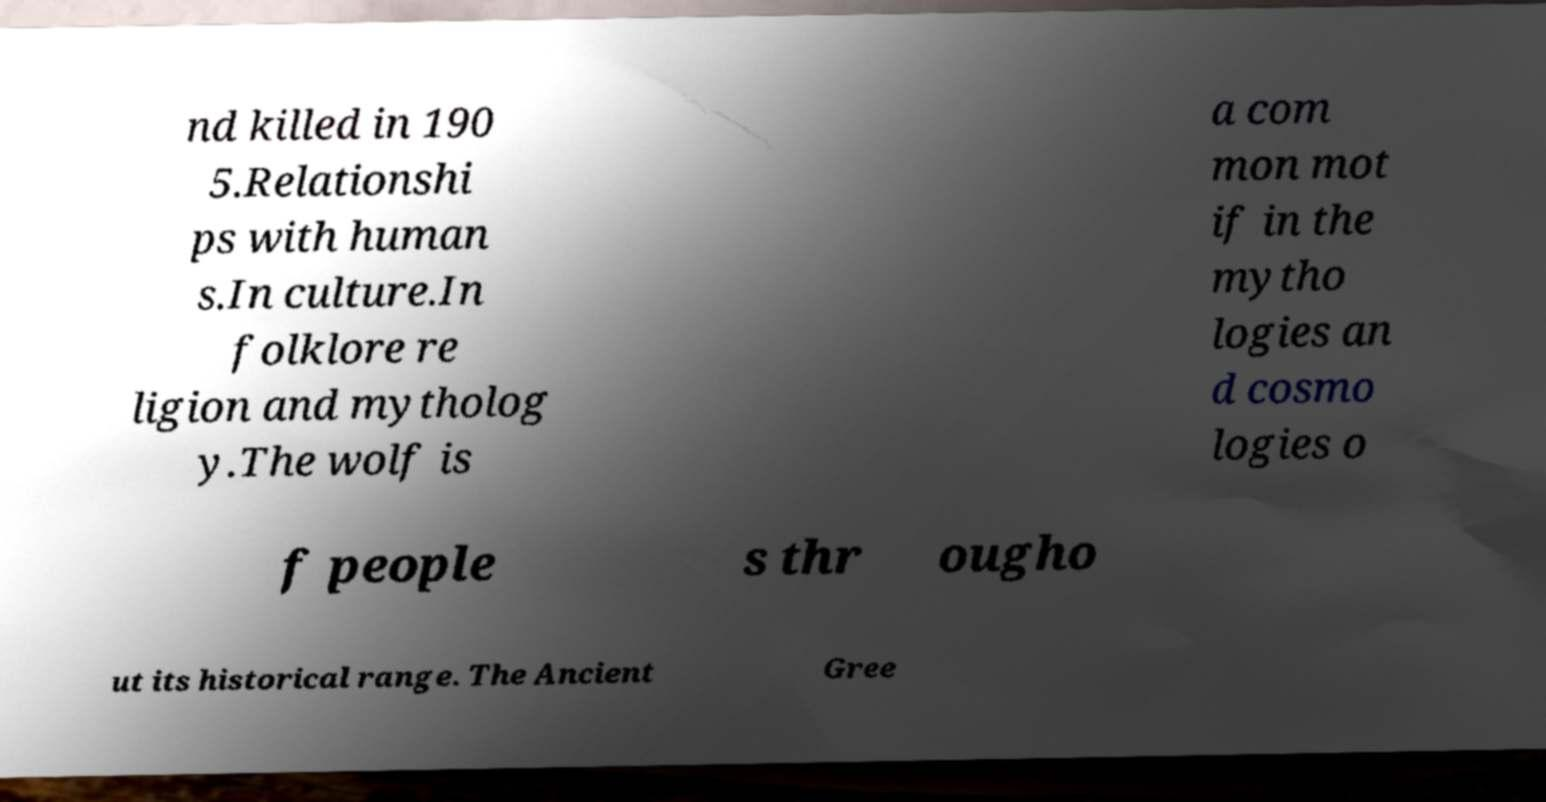What messages or text are displayed in this image? I need them in a readable, typed format. nd killed in 190 5.Relationshi ps with human s.In culture.In folklore re ligion and mytholog y.The wolf is a com mon mot if in the mytho logies an d cosmo logies o f people s thr ougho ut its historical range. The Ancient Gree 